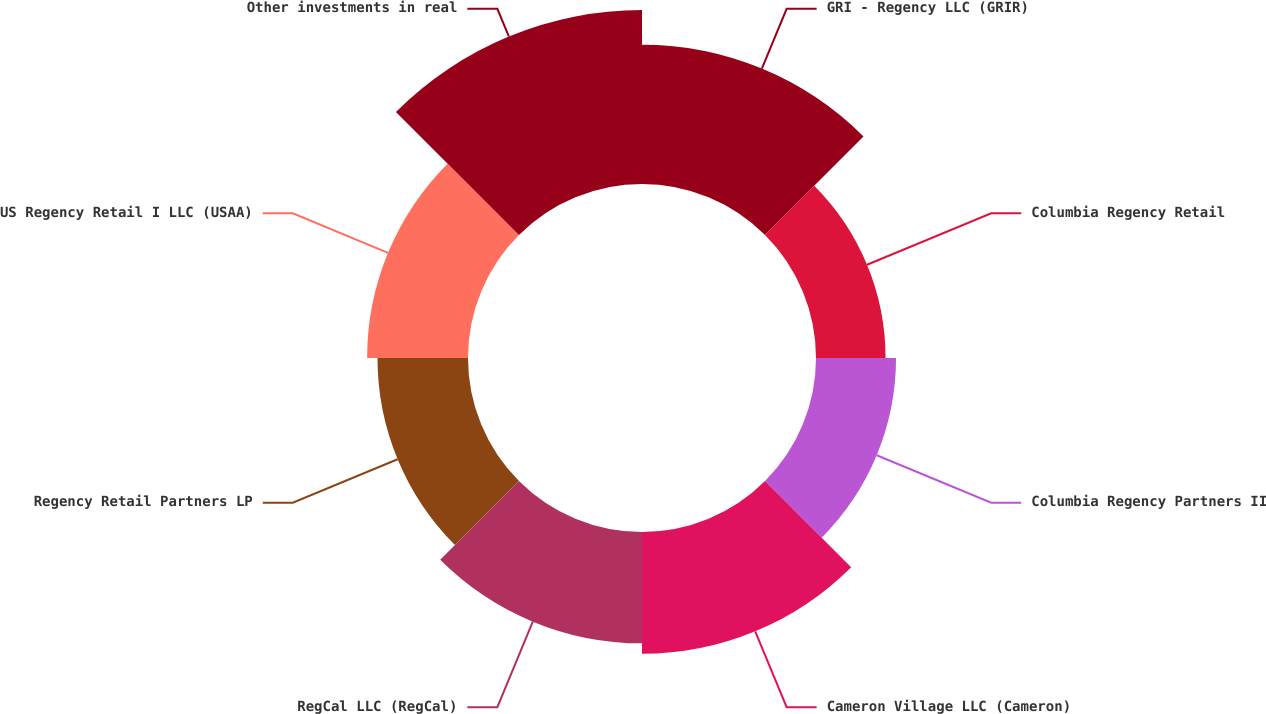Convert chart. <chart><loc_0><loc_0><loc_500><loc_500><pie_chart><fcel>GRI - Regency LLC (GRIR)<fcel>Columbia Regency Retail<fcel>Columbia Regency Partners II<fcel>Cameron Village LLC (Cameron)<fcel>RegCal LLC (RegCal)<fcel>Regency Retail Partners LP<fcel>US Regency Retail I LLC (USAA)<fcel>Other investments in real<nl><fcel>15.69%<fcel>7.84%<fcel>9.02%<fcel>13.73%<fcel>12.55%<fcel>10.2%<fcel>11.37%<fcel>19.61%<nl></chart> 